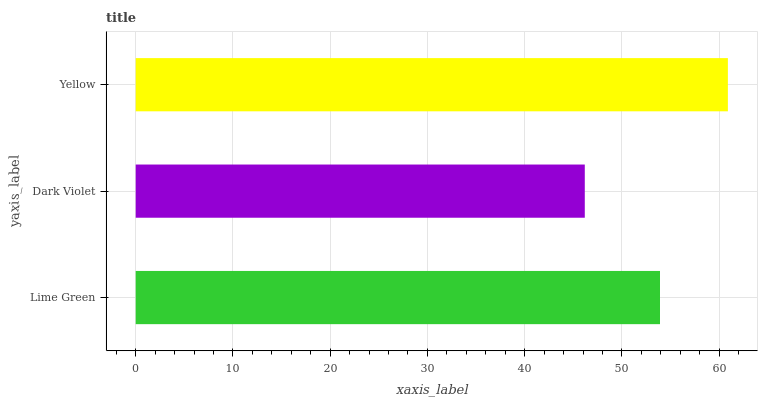Is Dark Violet the minimum?
Answer yes or no. Yes. Is Yellow the maximum?
Answer yes or no. Yes. Is Yellow the minimum?
Answer yes or no. No. Is Dark Violet the maximum?
Answer yes or no. No. Is Yellow greater than Dark Violet?
Answer yes or no. Yes. Is Dark Violet less than Yellow?
Answer yes or no. Yes. Is Dark Violet greater than Yellow?
Answer yes or no. No. Is Yellow less than Dark Violet?
Answer yes or no. No. Is Lime Green the high median?
Answer yes or no. Yes. Is Lime Green the low median?
Answer yes or no. Yes. Is Yellow the high median?
Answer yes or no. No. Is Dark Violet the low median?
Answer yes or no. No. 